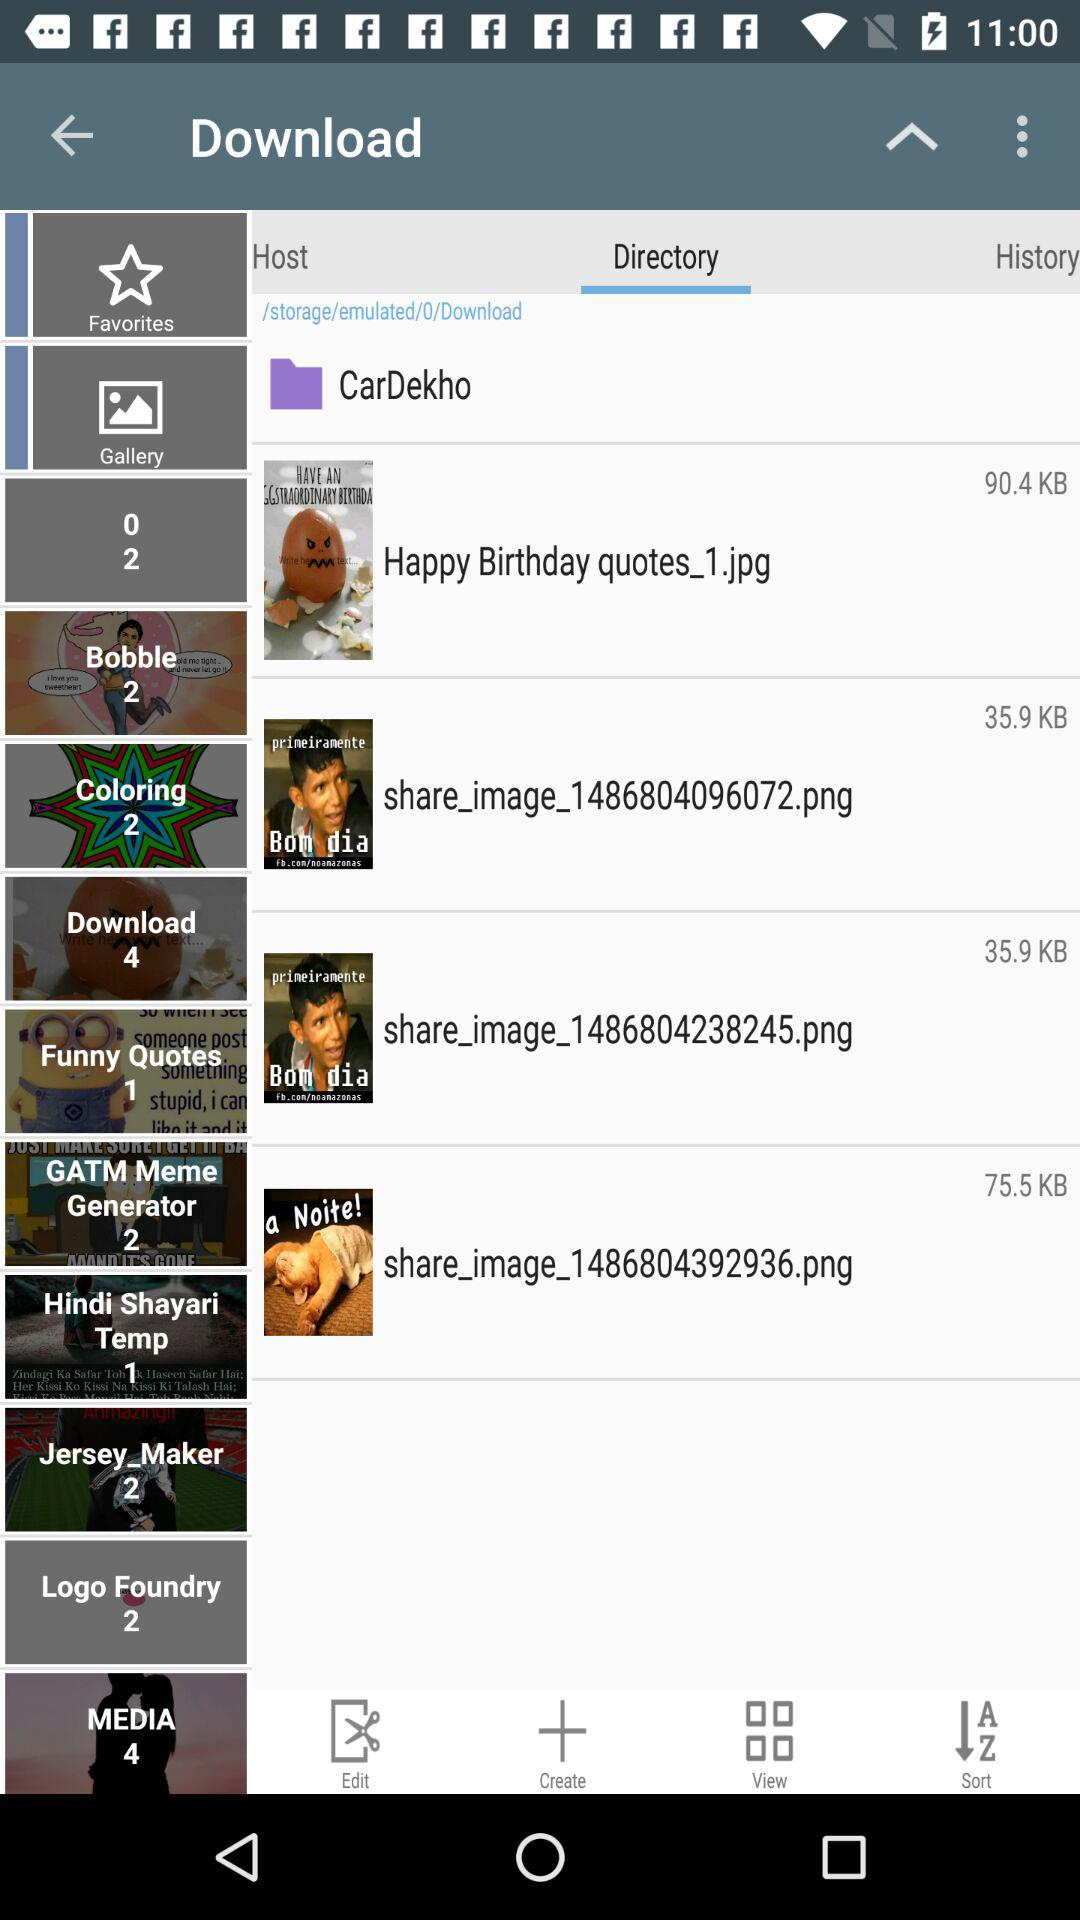How many items are in "History"?
When the provided information is insufficient, respond with <no answer>. <no answer> 